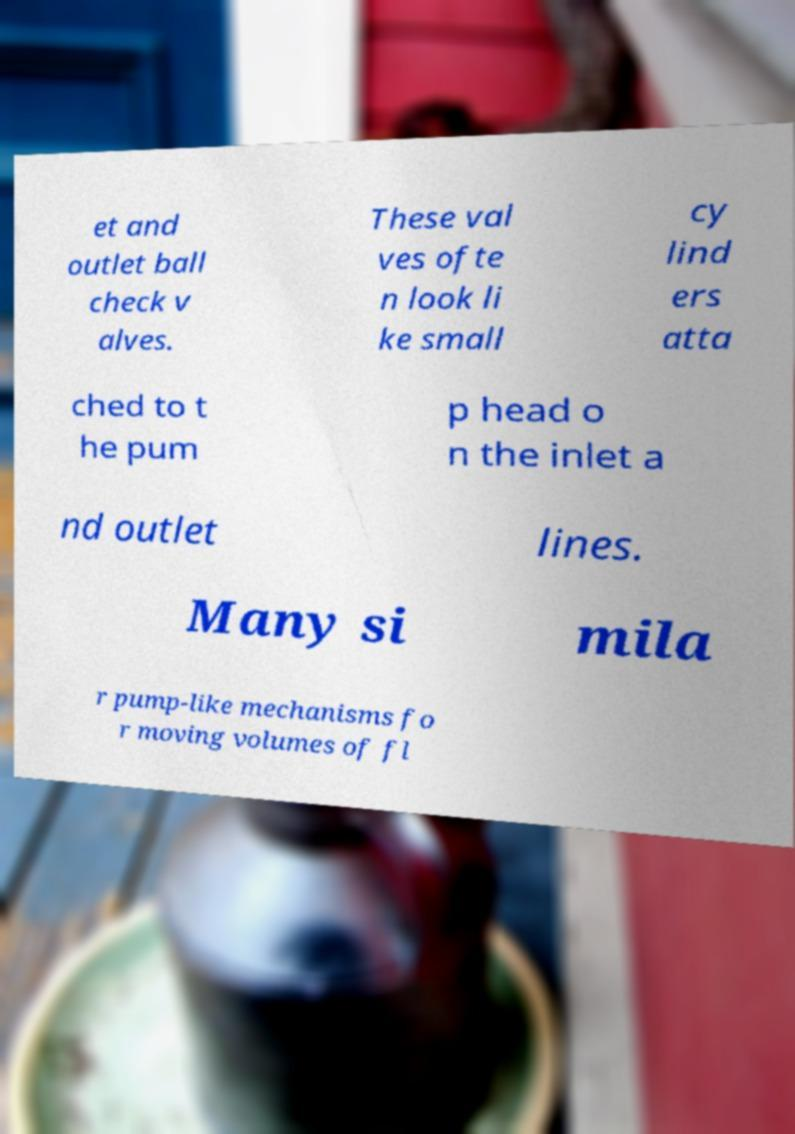Please identify and transcribe the text found in this image. et and outlet ball check v alves. These val ves ofte n look li ke small cy lind ers atta ched to t he pum p head o n the inlet a nd outlet lines. Many si mila r pump-like mechanisms fo r moving volumes of fl 